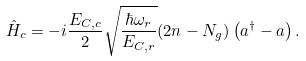Convert formula to latex. <formula><loc_0><loc_0><loc_500><loc_500>\hat { H } _ { c } = - i \frac { E _ { C , c } } { 2 } \sqrt { \frac { \hbar { \omega } _ { r } } { E _ { C , r } } } ( 2 n - N _ { g } ) \left ( a ^ { \dagger } - a \right ) .</formula> 